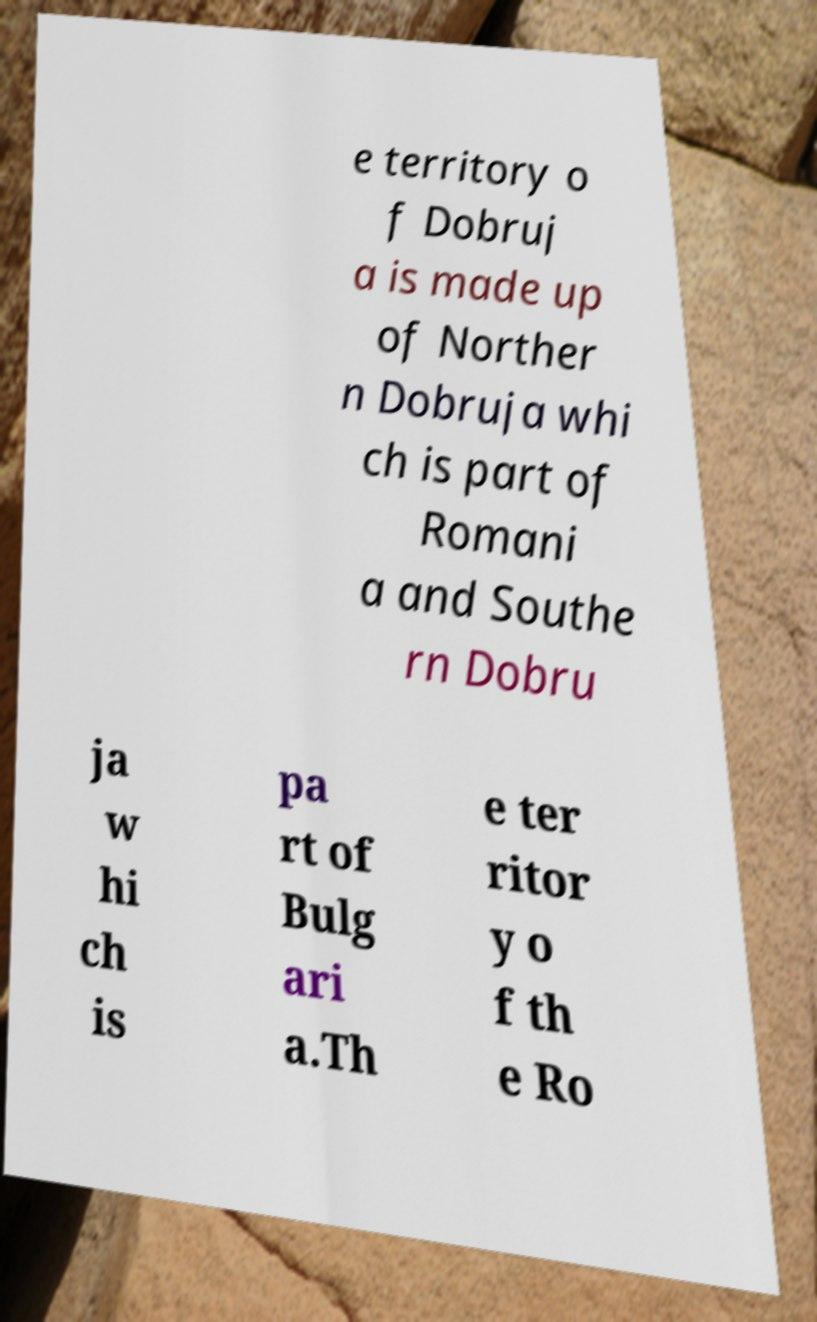Please identify and transcribe the text found in this image. e territory o f Dobruj a is made up of Norther n Dobruja whi ch is part of Romani a and Southe rn Dobru ja w hi ch is pa rt of Bulg ari a.Th e ter ritor y o f th e Ro 